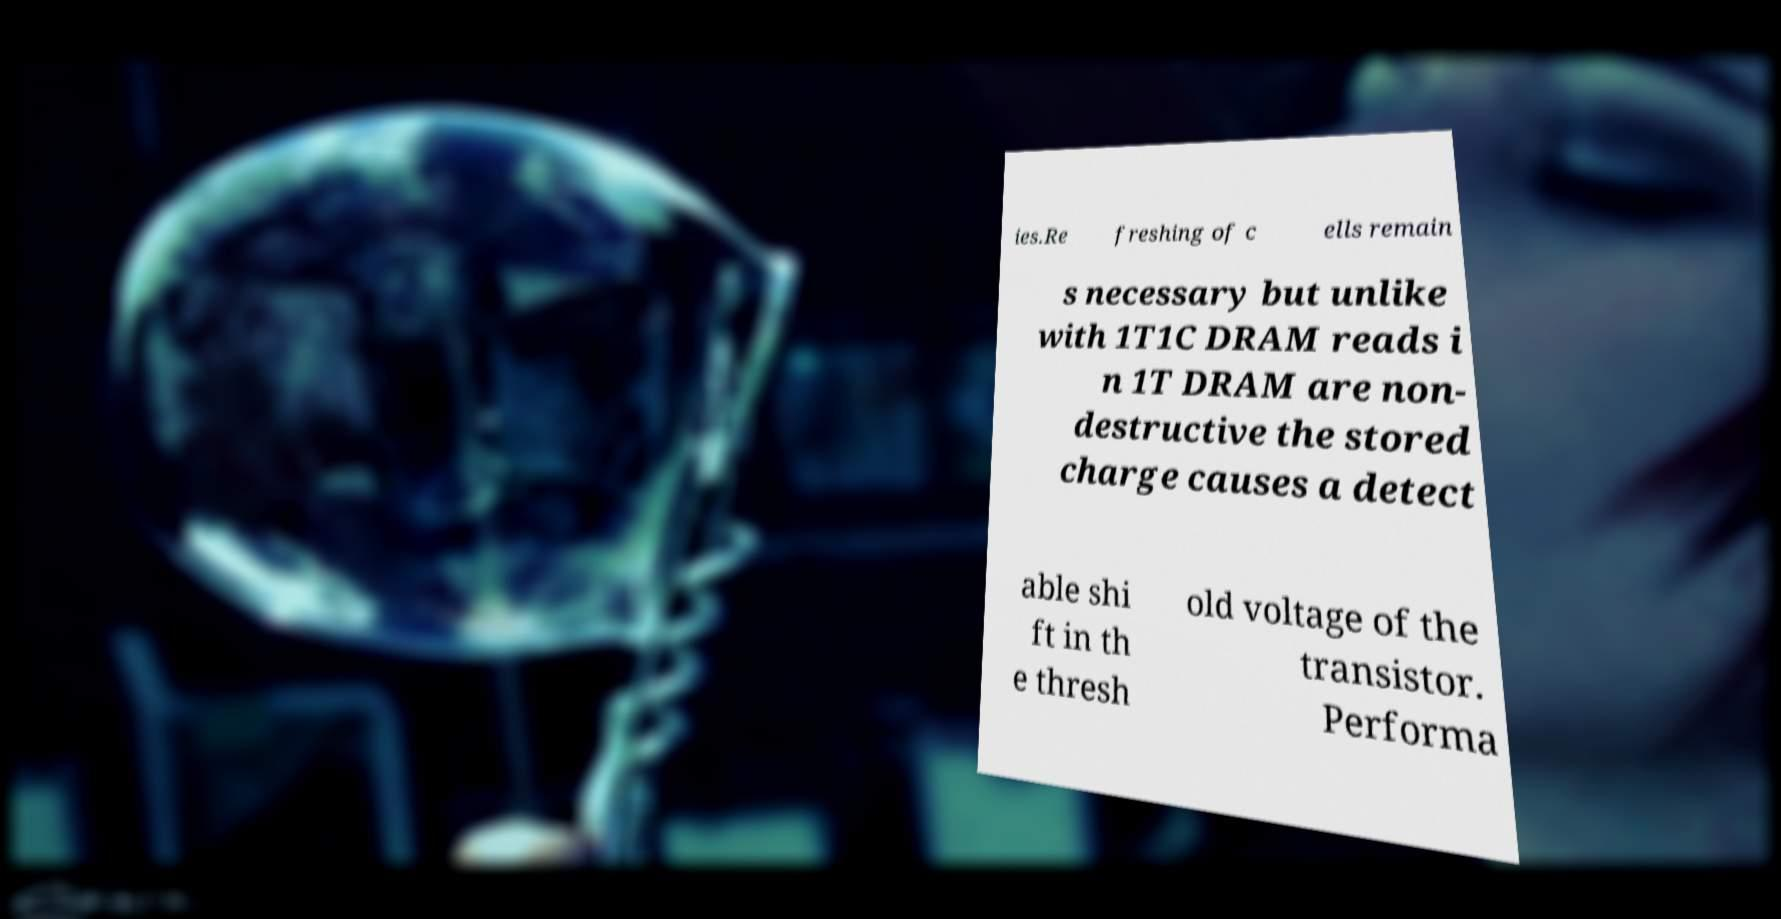Could you extract and type out the text from this image? ies.Re freshing of c ells remain s necessary but unlike with 1T1C DRAM reads i n 1T DRAM are non- destructive the stored charge causes a detect able shi ft in th e thresh old voltage of the transistor. Performa 